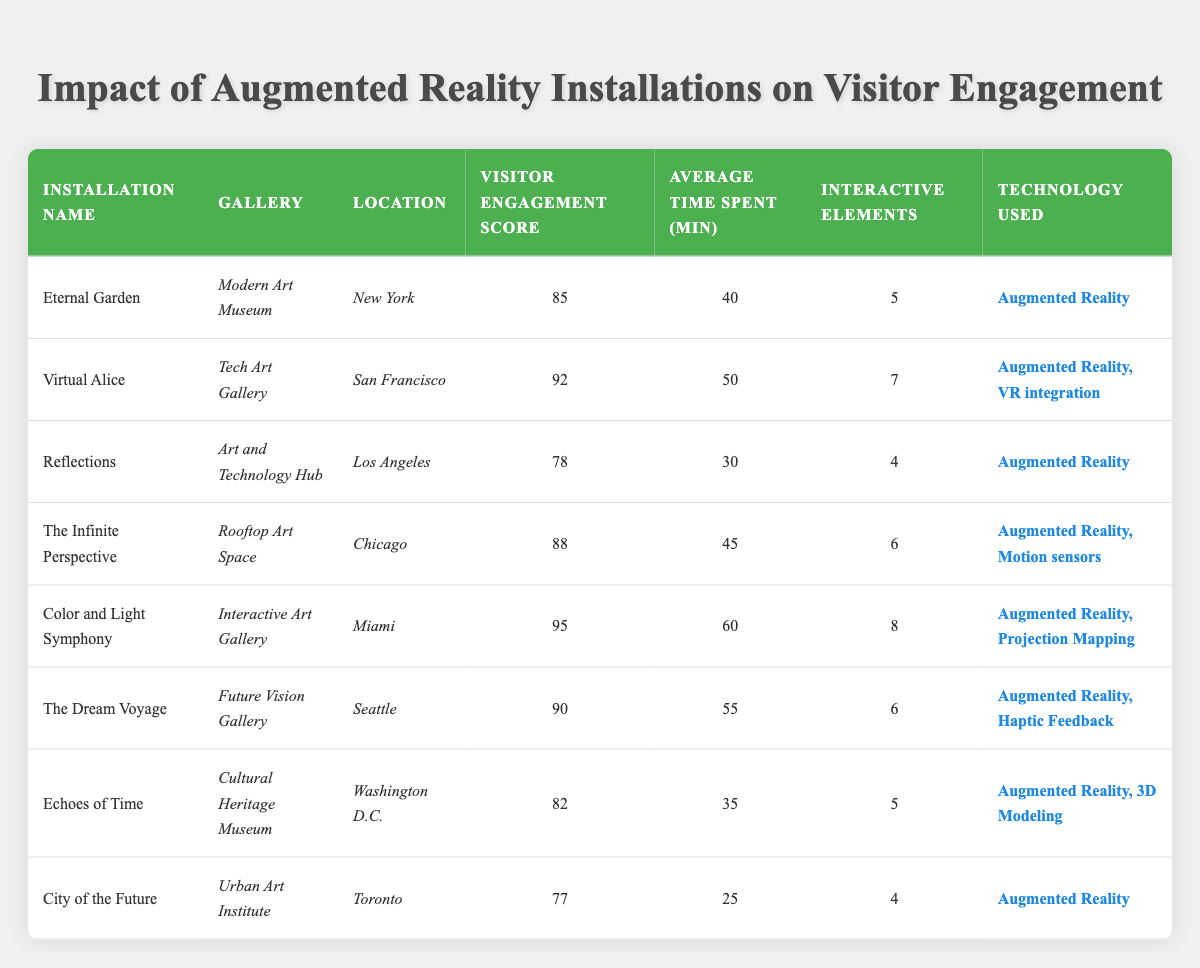What is the visitor engagement score for "The Dream Voyage"? The table lists the details of the installations, and for "The Dream Voyage," the visitor engagement score is indicated as 90.
Answer: 90 Which installation has the highest visitor engagement score? In the table, the installation names and their corresponding engagement scores are compared. "Color and Light Symphony" has the highest score of 95.
Answer: Color and Light Symphony What is the average time spent by visitors on installations using only Augmented Reality technology? To find the average time, we gather the average time spent for installations that utilize only Augmented Reality, which are "Eternal Garden" (40), "Reflections" (30), "Echoes of Time" (35), and "City of the Future" (25). The sum is (40 + 30 + 35 + 25 = 130) and since there are 4 installations, the average is 130/4 = 32.5 minutes.
Answer: 32.5 Is there an installation with more than 6 interactive elements that scores below 80 in visitor engagement? By examining the table, we see "City of the Future" with 4 interactive elements and a score of 77. All installations with more than 6 interactive elements score above 80, so no such installation exists.
Answer: No How many installations are located in Chicago? Looking through the table, we find that "The Infinite Perspective" is the only installation listed in Chicago.
Answer: 1 What is the total number of interactive elements in installations located in Miami and Seattle? For Miami, "Color and Light Symphony" has 8 interactive elements, and for Seattle, "The Dream Voyage" has 6 interactive elements. Adding these together gives us 8 + 6 = 14.
Answer: 14 Does the gallery with the lowest engagement score also have the least time spent by visitors? The lowest engagement score is for "City of the Future" (77) with an average time of 25 minutes. The next lowest score is for "Reflections" (78) with 30 minutes. So, yes, the gallery with the lowest engagement score has the least time spent.
Answer: Yes What is the median visitor engagement score of all installations listed? The visitor engagement scores in order are: 77, 78, 82, 85, 88, 90, 92, 95. The median is between the 4th and 5th values, which are 85 and 88. Therefore, the median is (85 + 88) / 2 = 86.5.
Answer: 86.5 